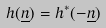Convert formula to latex. <formula><loc_0><loc_0><loc_500><loc_500>h ( \underline { n } ) = h ^ { * } ( - \underline { n } )</formula> 